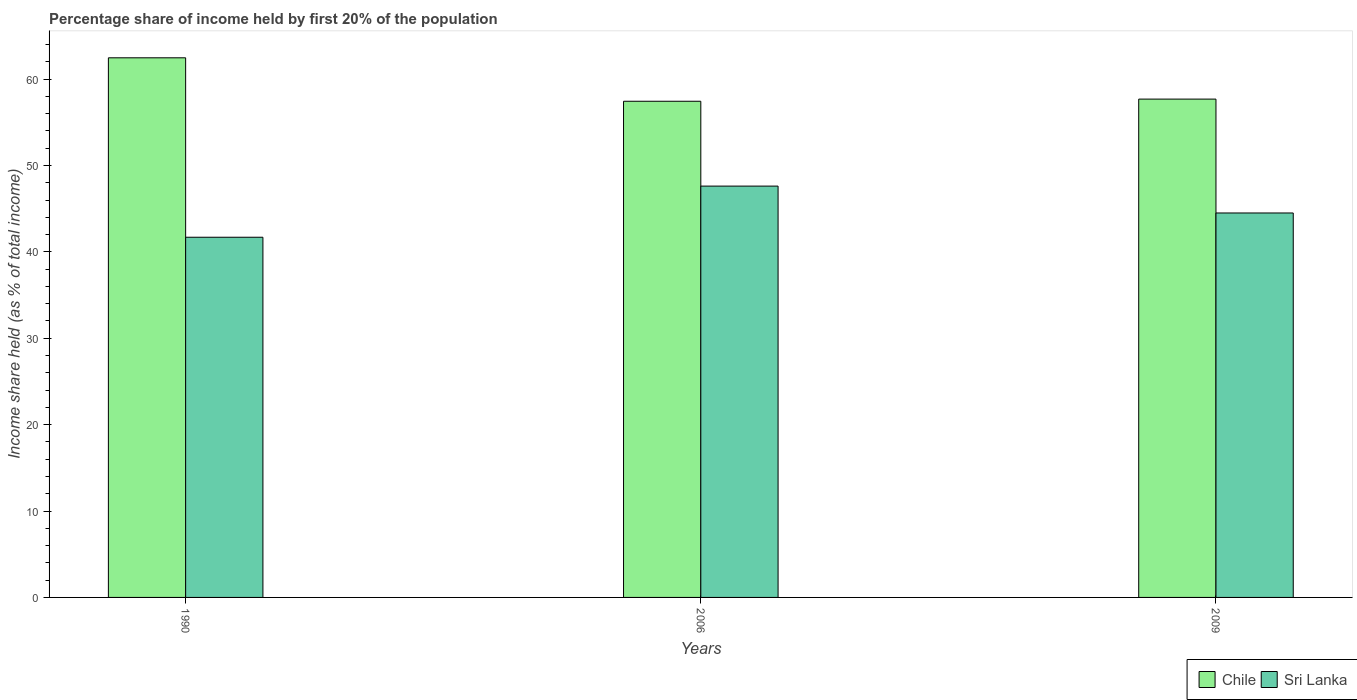How many groups of bars are there?
Keep it short and to the point. 3. Are the number of bars on each tick of the X-axis equal?
Give a very brief answer. Yes. How many bars are there on the 3rd tick from the right?
Your answer should be compact. 2. In how many cases, is the number of bars for a given year not equal to the number of legend labels?
Your answer should be compact. 0. What is the share of income held by first 20% of the population in Chile in 2006?
Keep it short and to the point. 57.43. Across all years, what is the maximum share of income held by first 20% of the population in Chile?
Make the answer very short. 62.46. Across all years, what is the minimum share of income held by first 20% of the population in Sri Lanka?
Provide a short and direct response. 41.69. In which year was the share of income held by first 20% of the population in Chile minimum?
Provide a succinct answer. 2006. What is the total share of income held by first 20% of the population in Sri Lanka in the graph?
Make the answer very short. 133.8. What is the difference between the share of income held by first 20% of the population in Sri Lanka in 1990 and that in 2009?
Make the answer very short. -2.81. What is the difference between the share of income held by first 20% of the population in Chile in 2009 and the share of income held by first 20% of the population in Sri Lanka in 2006?
Offer a terse response. 10.07. What is the average share of income held by first 20% of the population in Sri Lanka per year?
Offer a very short reply. 44.6. In the year 2009, what is the difference between the share of income held by first 20% of the population in Chile and share of income held by first 20% of the population in Sri Lanka?
Your answer should be compact. 13.18. In how many years, is the share of income held by first 20% of the population in Sri Lanka greater than 52 %?
Keep it short and to the point. 0. What is the ratio of the share of income held by first 20% of the population in Chile in 1990 to that in 2006?
Your answer should be very brief. 1.09. Is the share of income held by first 20% of the population in Sri Lanka in 1990 less than that in 2006?
Keep it short and to the point. Yes. What is the difference between the highest and the second highest share of income held by first 20% of the population in Chile?
Your response must be concise. 4.78. What is the difference between the highest and the lowest share of income held by first 20% of the population in Sri Lanka?
Ensure brevity in your answer.  5.92. In how many years, is the share of income held by first 20% of the population in Chile greater than the average share of income held by first 20% of the population in Chile taken over all years?
Your answer should be very brief. 1. Is the sum of the share of income held by first 20% of the population in Sri Lanka in 1990 and 2006 greater than the maximum share of income held by first 20% of the population in Chile across all years?
Provide a succinct answer. Yes. What does the 1st bar from the right in 2006 represents?
Offer a very short reply. Sri Lanka. How many bars are there?
Ensure brevity in your answer.  6. How many years are there in the graph?
Offer a terse response. 3. What is the difference between two consecutive major ticks on the Y-axis?
Keep it short and to the point. 10. Does the graph contain any zero values?
Your answer should be compact. No. Where does the legend appear in the graph?
Provide a short and direct response. Bottom right. How many legend labels are there?
Provide a short and direct response. 2. How are the legend labels stacked?
Give a very brief answer. Horizontal. What is the title of the graph?
Provide a succinct answer. Percentage share of income held by first 20% of the population. Does "Cyprus" appear as one of the legend labels in the graph?
Your answer should be very brief. No. What is the label or title of the Y-axis?
Your answer should be very brief. Income share held (as % of total income). What is the Income share held (as % of total income) in Chile in 1990?
Offer a very short reply. 62.46. What is the Income share held (as % of total income) of Sri Lanka in 1990?
Keep it short and to the point. 41.69. What is the Income share held (as % of total income) of Chile in 2006?
Your response must be concise. 57.43. What is the Income share held (as % of total income) in Sri Lanka in 2006?
Provide a short and direct response. 47.61. What is the Income share held (as % of total income) of Chile in 2009?
Ensure brevity in your answer.  57.68. What is the Income share held (as % of total income) of Sri Lanka in 2009?
Provide a short and direct response. 44.5. Across all years, what is the maximum Income share held (as % of total income) of Chile?
Offer a terse response. 62.46. Across all years, what is the maximum Income share held (as % of total income) in Sri Lanka?
Provide a short and direct response. 47.61. Across all years, what is the minimum Income share held (as % of total income) of Chile?
Offer a very short reply. 57.43. Across all years, what is the minimum Income share held (as % of total income) of Sri Lanka?
Offer a terse response. 41.69. What is the total Income share held (as % of total income) in Chile in the graph?
Provide a succinct answer. 177.57. What is the total Income share held (as % of total income) of Sri Lanka in the graph?
Provide a short and direct response. 133.8. What is the difference between the Income share held (as % of total income) of Chile in 1990 and that in 2006?
Keep it short and to the point. 5.03. What is the difference between the Income share held (as % of total income) in Sri Lanka in 1990 and that in 2006?
Offer a terse response. -5.92. What is the difference between the Income share held (as % of total income) in Chile in 1990 and that in 2009?
Your response must be concise. 4.78. What is the difference between the Income share held (as % of total income) of Sri Lanka in 1990 and that in 2009?
Your answer should be compact. -2.81. What is the difference between the Income share held (as % of total income) of Sri Lanka in 2006 and that in 2009?
Your answer should be very brief. 3.11. What is the difference between the Income share held (as % of total income) in Chile in 1990 and the Income share held (as % of total income) in Sri Lanka in 2006?
Your answer should be compact. 14.85. What is the difference between the Income share held (as % of total income) in Chile in 1990 and the Income share held (as % of total income) in Sri Lanka in 2009?
Your answer should be compact. 17.96. What is the difference between the Income share held (as % of total income) in Chile in 2006 and the Income share held (as % of total income) in Sri Lanka in 2009?
Provide a short and direct response. 12.93. What is the average Income share held (as % of total income) of Chile per year?
Make the answer very short. 59.19. What is the average Income share held (as % of total income) of Sri Lanka per year?
Provide a succinct answer. 44.6. In the year 1990, what is the difference between the Income share held (as % of total income) in Chile and Income share held (as % of total income) in Sri Lanka?
Your answer should be compact. 20.77. In the year 2006, what is the difference between the Income share held (as % of total income) in Chile and Income share held (as % of total income) in Sri Lanka?
Your answer should be compact. 9.82. In the year 2009, what is the difference between the Income share held (as % of total income) of Chile and Income share held (as % of total income) of Sri Lanka?
Keep it short and to the point. 13.18. What is the ratio of the Income share held (as % of total income) in Chile in 1990 to that in 2006?
Provide a succinct answer. 1.09. What is the ratio of the Income share held (as % of total income) of Sri Lanka in 1990 to that in 2006?
Your answer should be compact. 0.88. What is the ratio of the Income share held (as % of total income) in Chile in 1990 to that in 2009?
Your answer should be compact. 1.08. What is the ratio of the Income share held (as % of total income) in Sri Lanka in 1990 to that in 2009?
Your answer should be very brief. 0.94. What is the ratio of the Income share held (as % of total income) in Chile in 2006 to that in 2009?
Offer a terse response. 1. What is the ratio of the Income share held (as % of total income) of Sri Lanka in 2006 to that in 2009?
Your answer should be very brief. 1.07. What is the difference between the highest and the second highest Income share held (as % of total income) of Chile?
Provide a succinct answer. 4.78. What is the difference between the highest and the second highest Income share held (as % of total income) in Sri Lanka?
Provide a short and direct response. 3.11. What is the difference between the highest and the lowest Income share held (as % of total income) in Chile?
Keep it short and to the point. 5.03. What is the difference between the highest and the lowest Income share held (as % of total income) in Sri Lanka?
Provide a succinct answer. 5.92. 